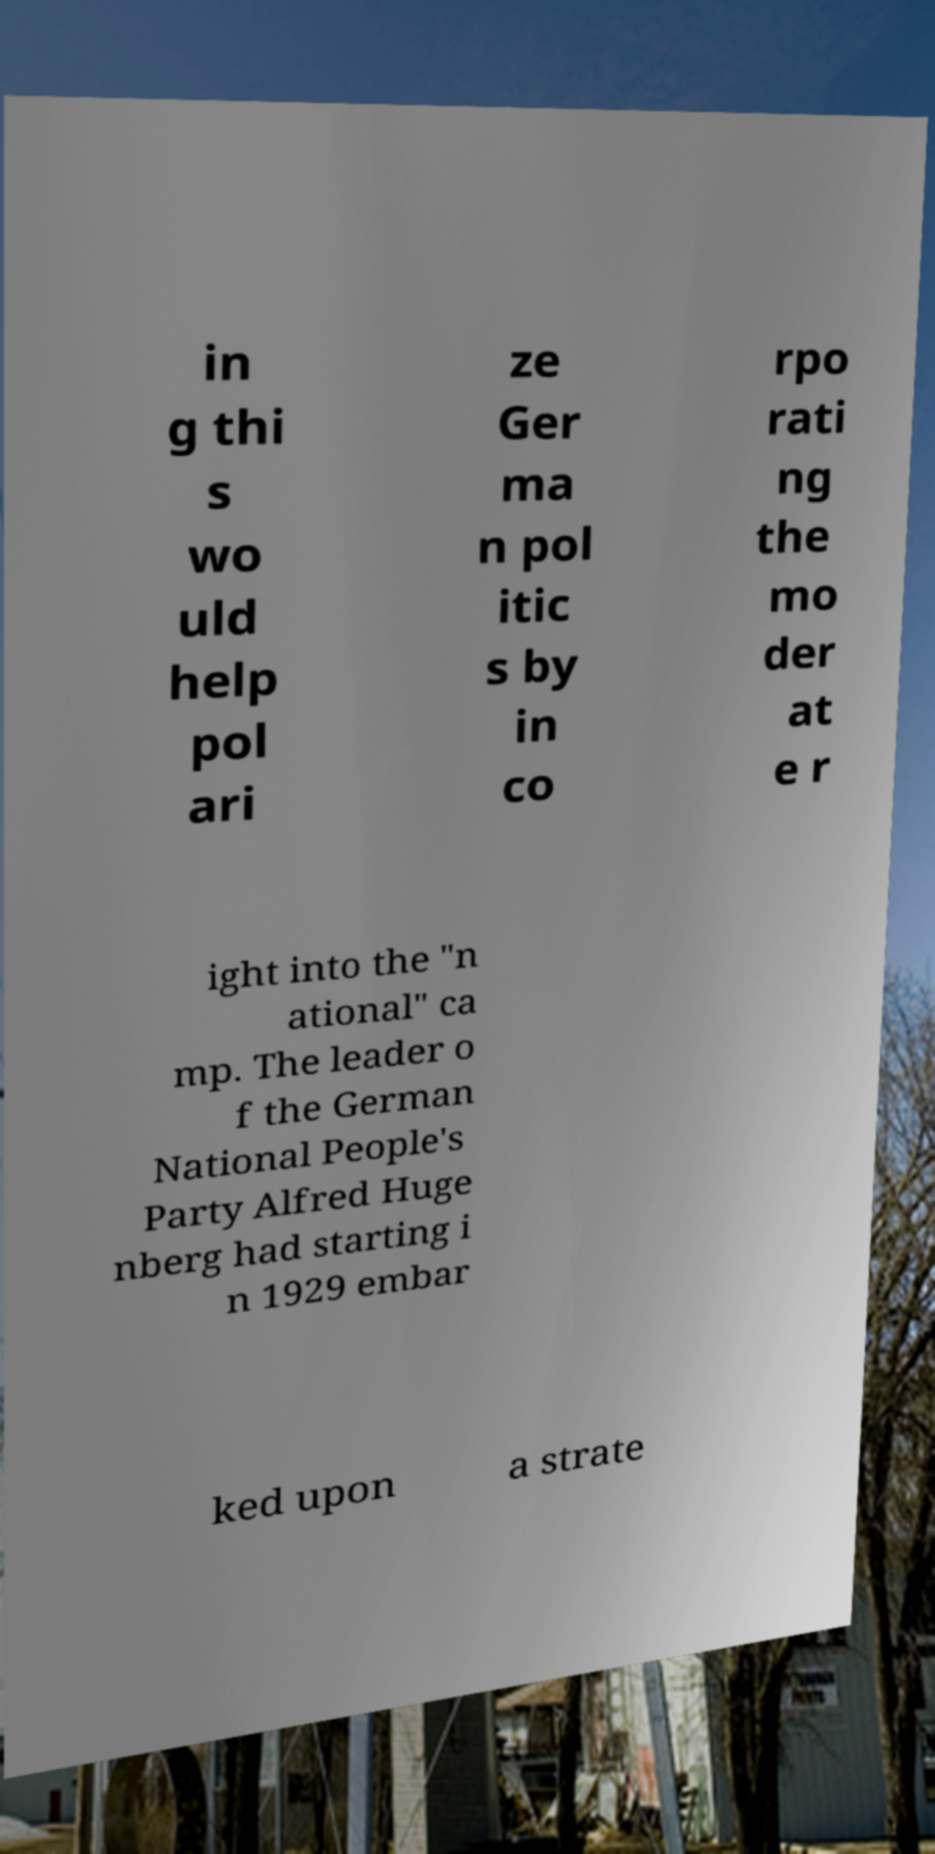Please identify and transcribe the text found in this image. in g thi s wo uld help pol ari ze Ger ma n pol itic s by in co rpo rati ng the mo der at e r ight into the "n ational" ca mp. The leader o f the German National People's Party Alfred Huge nberg had starting i n 1929 embar ked upon a strate 